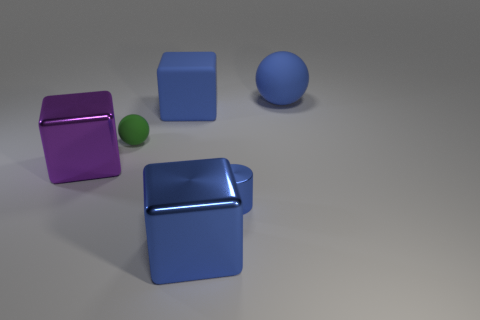Add 3 shiny cubes. How many objects exist? 9 Subtract all spheres. How many objects are left? 4 Add 6 blue balls. How many blue balls exist? 7 Subtract 0 red blocks. How many objects are left? 6 Subtract all metallic cylinders. Subtract all big blue matte balls. How many objects are left? 4 Add 1 big things. How many big things are left? 5 